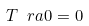<formula> <loc_0><loc_0><loc_500><loc_500>T \ r a { 0 } = 0</formula> 